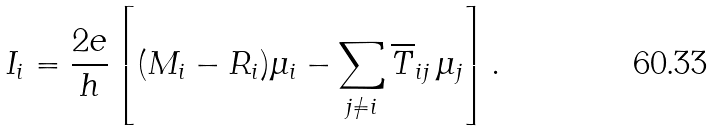<formula> <loc_0><loc_0><loc_500><loc_500>I _ { i } = \frac { 2 e } { h } \left [ ( M _ { i } - R _ { i } ) \mu _ { i } - \sum _ { j \ne i } \overline { T } _ { i j } \, \mu _ { j } \right ] .</formula> 